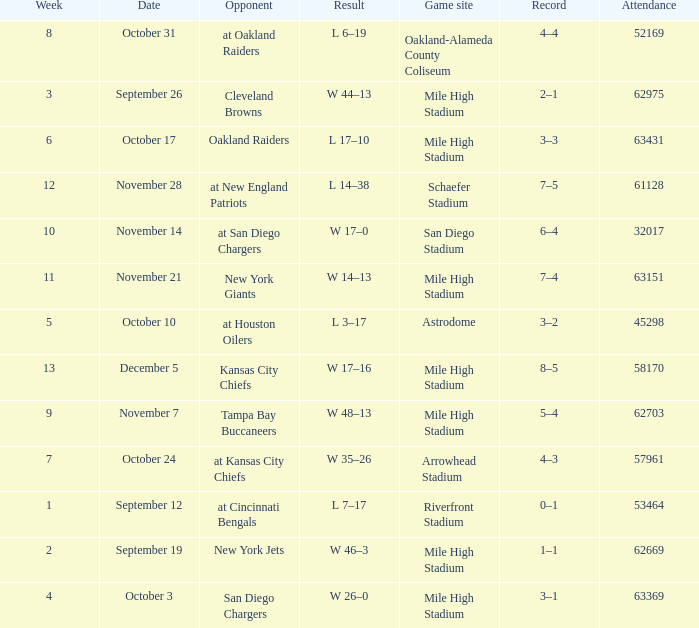What was the week number when the opponent was the New York Jets? 2.0. 